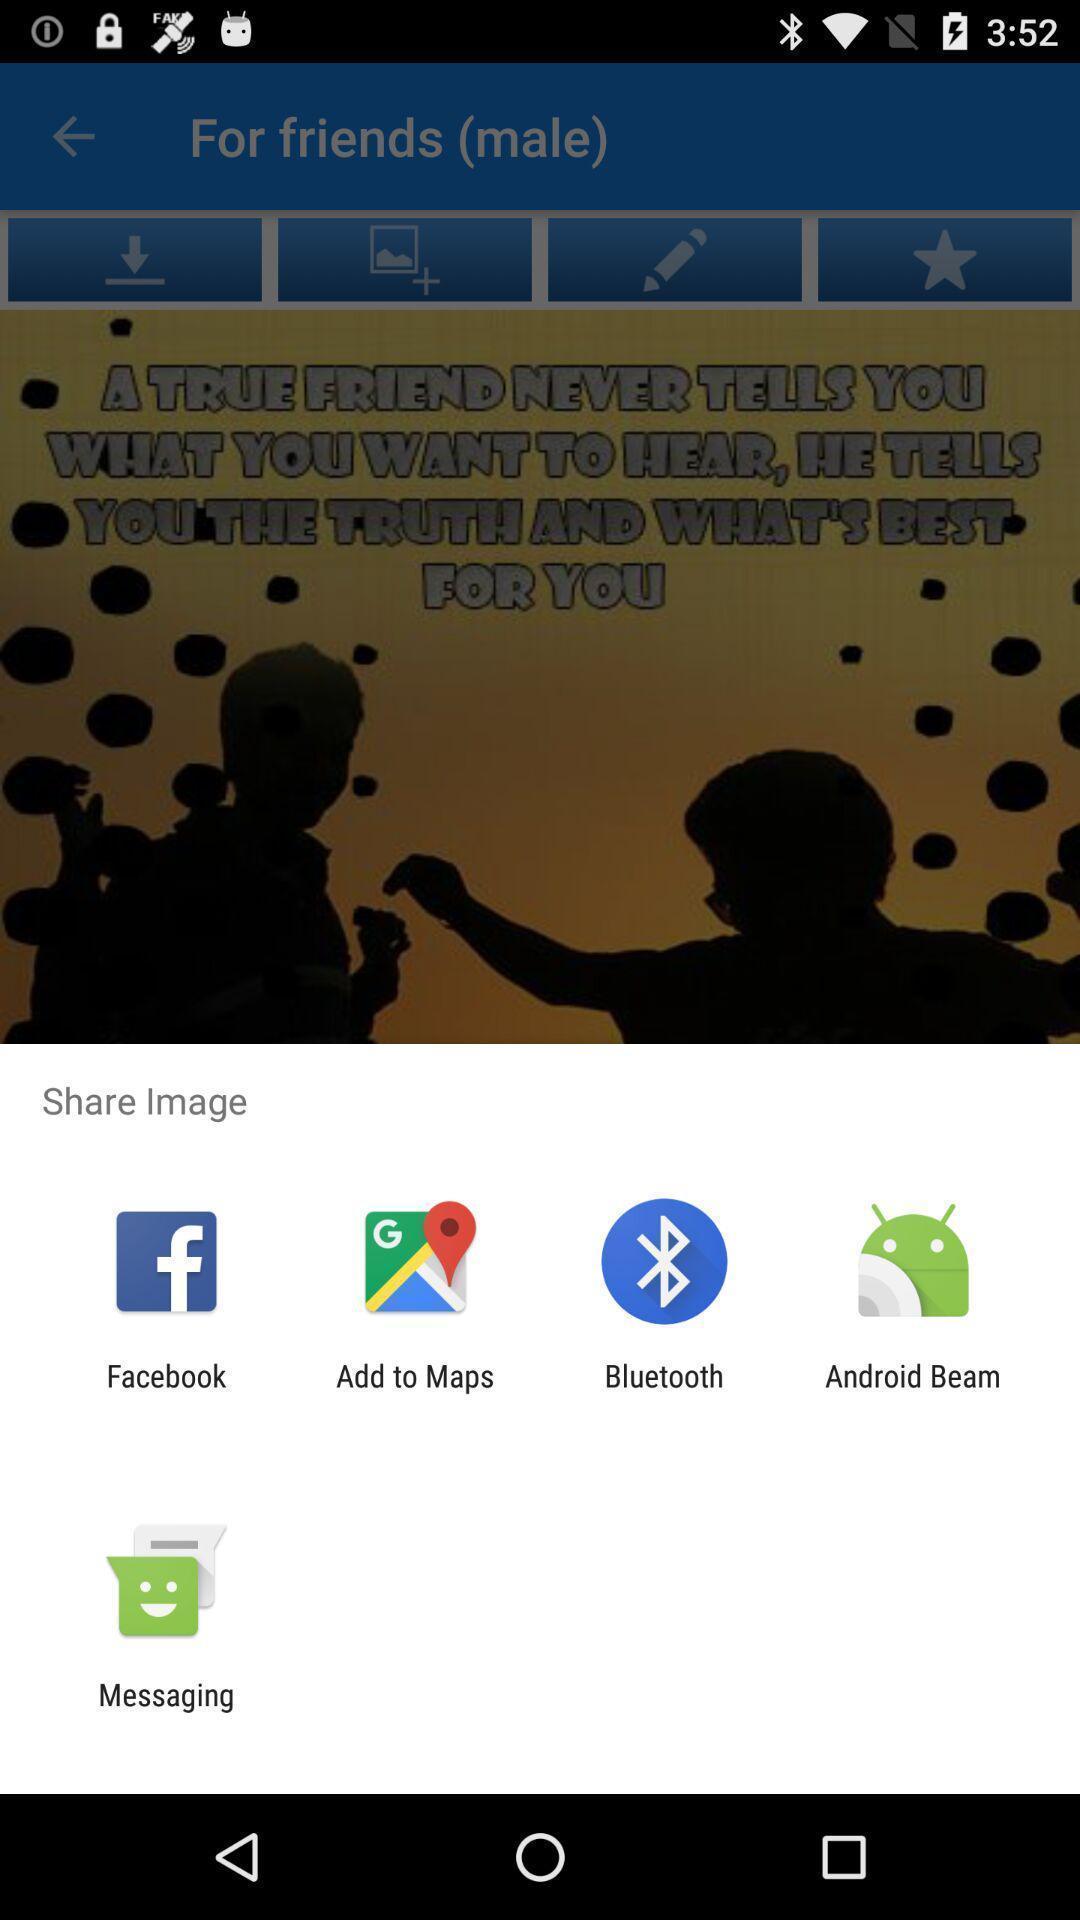What is the overall content of this screenshot? Share the image with different apps. 